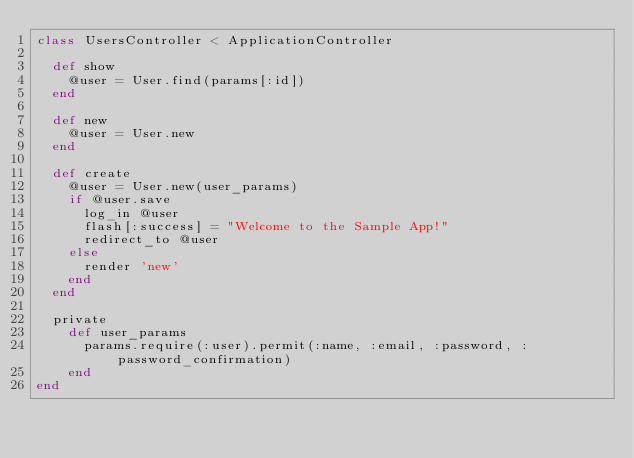Convert code to text. <code><loc_0><loc_0><loc_500><loc_500><_Ruby_>class UsersController < ApplicationController
  
  def show
    @user = User.find(params[:id])
  end

  def new
    @user = User.new
  end

  def create
    @user = User.new(user_params)
    if @user.save
      log_in @user
      flash[:success] = "Welcome to the Sample App!"
      redirect_to @user
    else
      render 'new'
    end
  end

  private
    def user_params
      params.require(:user).permit(:name, :email, :password, :password_confirmation)
    end
end
</code> 